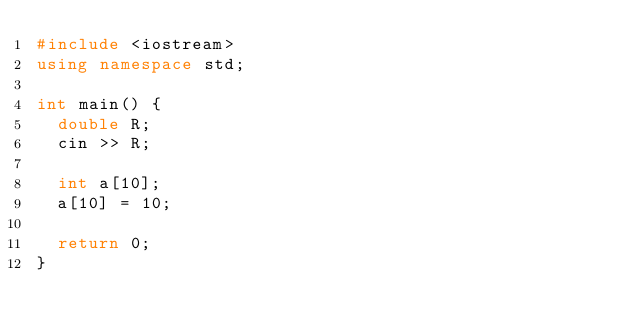Convert code to text. <code><loc_0><loc_0><loc_500><loc_500><_C++_>#include <iostream>
using namespace std;

int main() {
  double R;
  cin >> R;
  
  int a[10];
  a[10] = 10;
  
  return 0;
}</code> 